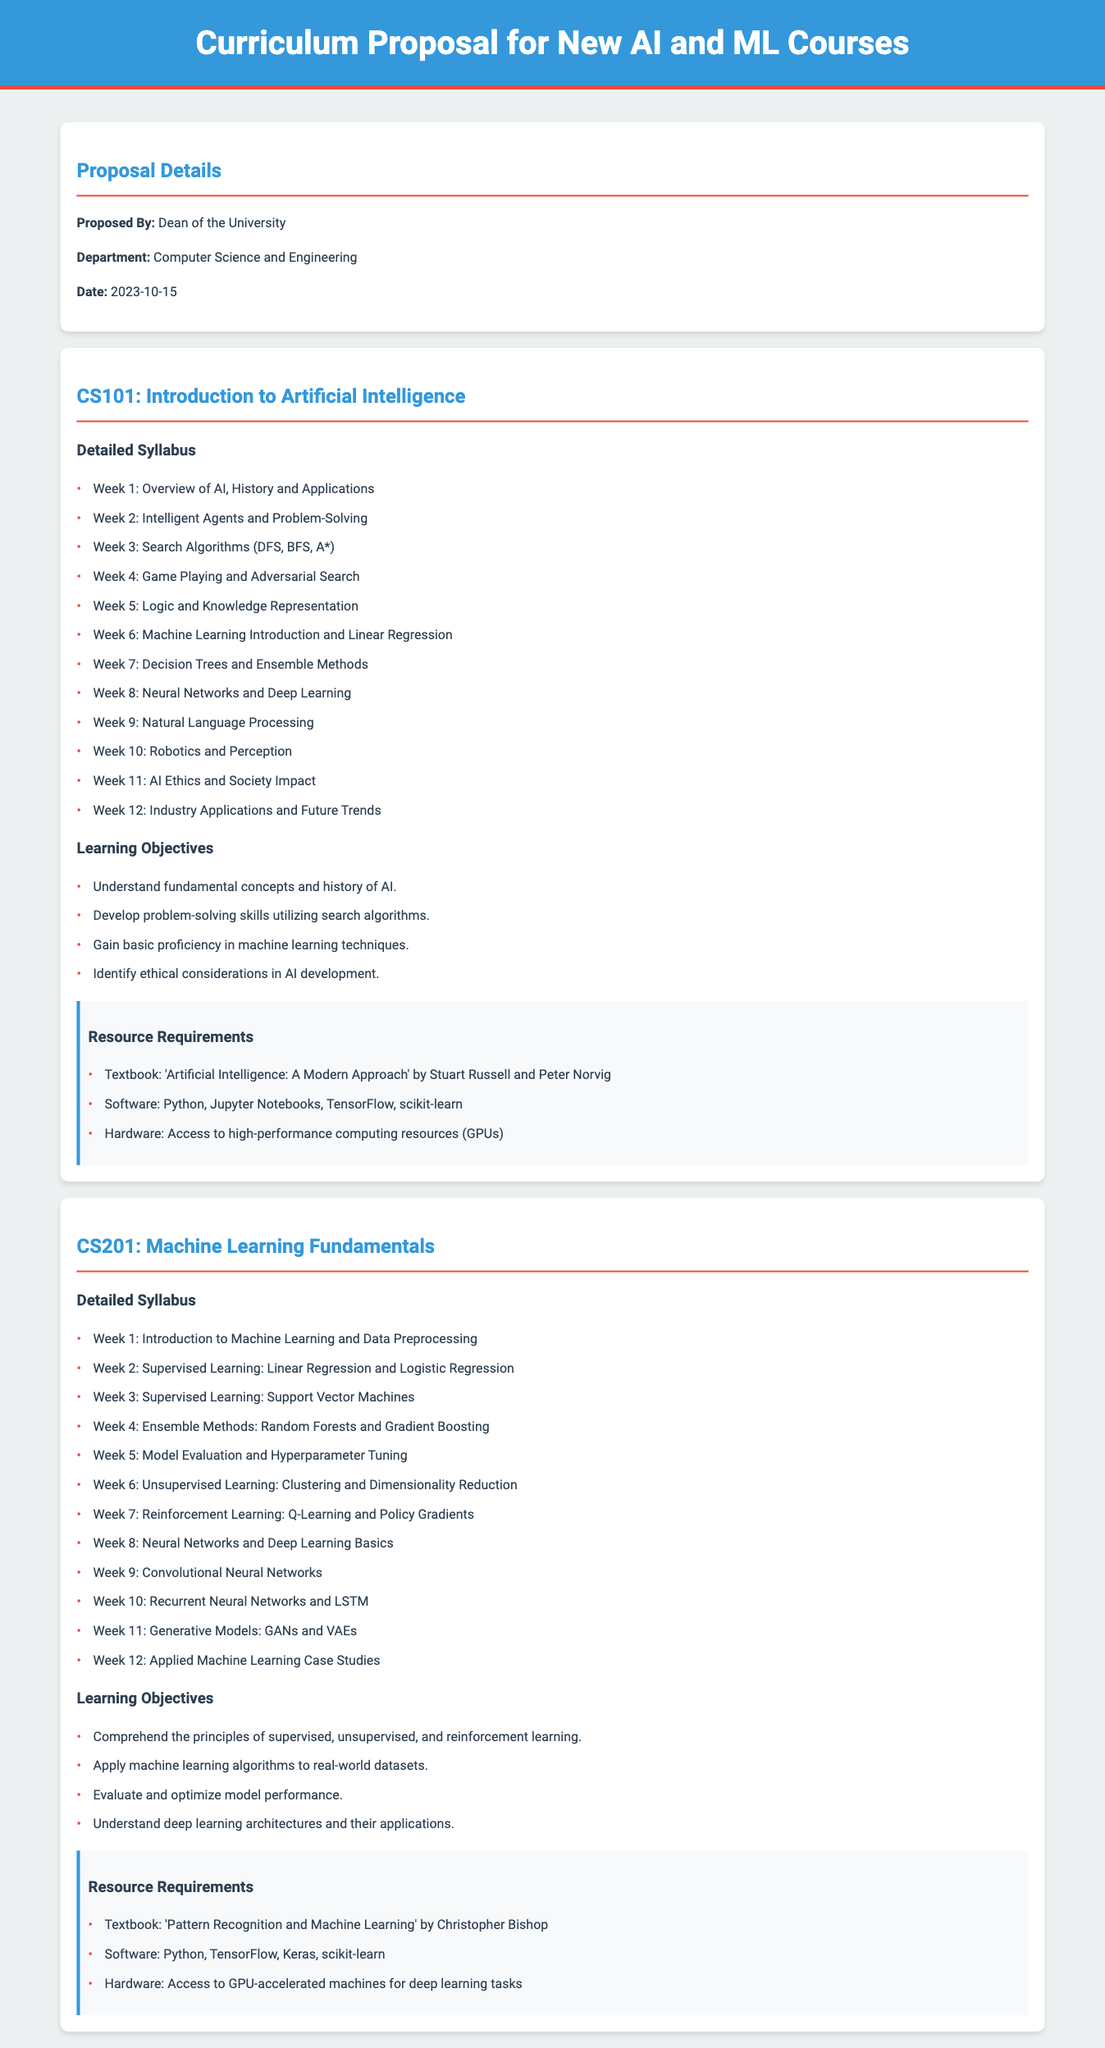What is the proposed date for the curriculum? The proposed date for the curriculum is mentioned in the proposal details section of the document.
Answer: 2023-10-15 Who is the proposed by? The name of the individual proposing the curriculum can be found in the proposal details section.
Answer: Dean of the University What is the title of the first course offered? The title of the first course can be identified in the course section of the document.
Answer: CS101: Introduction to Artificial Intelligence What is one of the learning objectives for CS201? The learning objectives for CS201 can be found in the course sections, detailing the goals of the curriculum.
Answer: Apply machine learning algorithms to real-world datasets How many weeks is CS101 scheduled for? The number of weeks scheduled for CS101 can be counted from the detailed syllabus section of the document.
Answer: 12 weeks What is one resource required for CS101? The resource requirements for CS101 are listed in the resource requirements section for that course.
Answer: Textbook: 'Artificial Intelligence: A Modern Approach' by Stuart Russell and Peter Norvig What method is taught in week 4 of CS201? The methods taught in each week are specified in the detailed syllabus of the document.
Answer: Ensemble Methods: Random Forests and Gradient Boosting What is a key topic addressed in CS101 related to ethics? The detailed syllabus mentions specific topics, including the ethical considerations in AI development.
Answer: AI Ethics and Society Impact What is the department proposing the courses? The department responsible for the proposal is specified in the proposal details section.
Answer: Computer Science and Engineering 